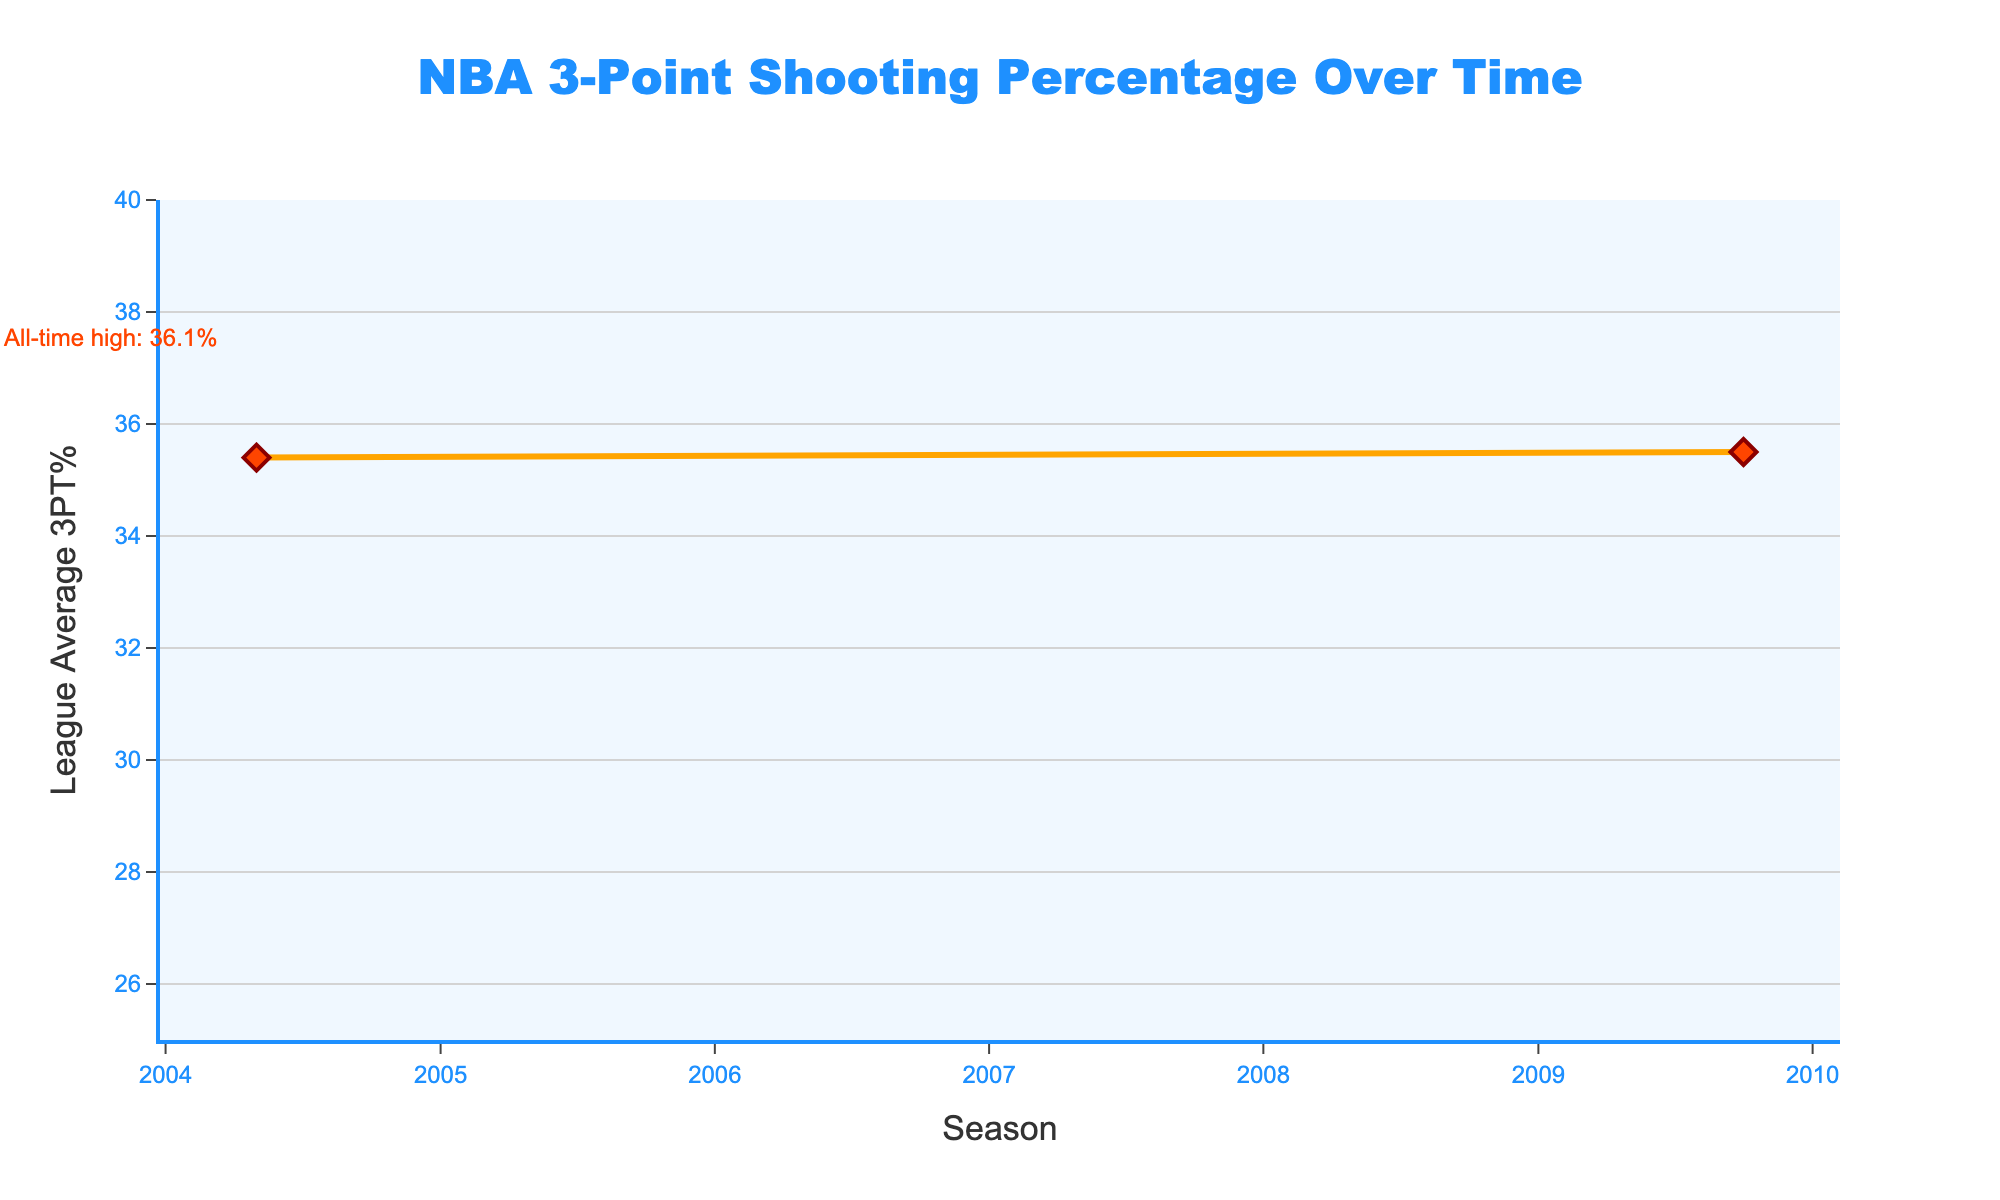What is the league average 3-point shooting percentage in the 2022-23 season? The league average 3PT% in the 2022-23 season is annotated directly in the figure.
Answer: 36.1% How does the league average 3-point shooting percentage in 1999-00 compare to 2019-20? By looking at the data points for 1999-00 and 2019-20, we can see that the 3PT% decreased from 34.1% to 35.8%.
Answer: It increased What is the difference between the highest and lowest league average 3PT% shown in the chart? Identify the highest value (36.1% in 2022-23) and the lowest value (28.0% in 1979-80) and find the difference: 36.1 - 28.0 = 8.1%.
Answer: 8.1% During which five-year interval did the league average 3PT% see the largest increase? Compare the differences between the successive years across all intervals. The interval from 1984-85 to 1989-90 shows an increase from 28.2% to 33.1%, which is an increase of 4.9 percentage points, the highest increase.
Answer: 1984-85 to 1989-90 What trend can be visualized between the years 2009-10 and 2014-15 in the league average 3PT%? Examine the slope between the two points, 35.5% in 2009-10 and 35.0% in 2014-15. The league average 3PT% showed a slight decrease.
Answer: A slight decrease What is the visual cue used to highlight the highest 3PT% in the chart? An annotation with an arrow is used to emphasize the highest 3PT% in 2022-23 at 36.1%.
Answer: An annotation with an arrow Was there any period where the league average 3PT% remained relatively constant for several seasons? Look at the periods where the slope of the line remains nearly flat. Between 2004-05 and 2009-10, the league average 3PT% is close to 35.4-35.5%.
Answer: Yes, between 2004-05 and 2009-10 How did the league average 3PT% change from the first to second recorded season in the chart? Compare the first two data points: 1979-80 (28.0%) and 1984-85 (28.2%). The percentage increased slightly by 0.2%.
Answer: It increased by 0.2% Can you identify a period of a sharp increase or decrease in the league average 3PT%? Identify steep slopes in the chart, such as the period between 1994-95 (35.9%) and 1999-00 (34.1%) which shows a noticeable sharp decrease.
Answer: 1994-95 to 1999-00 